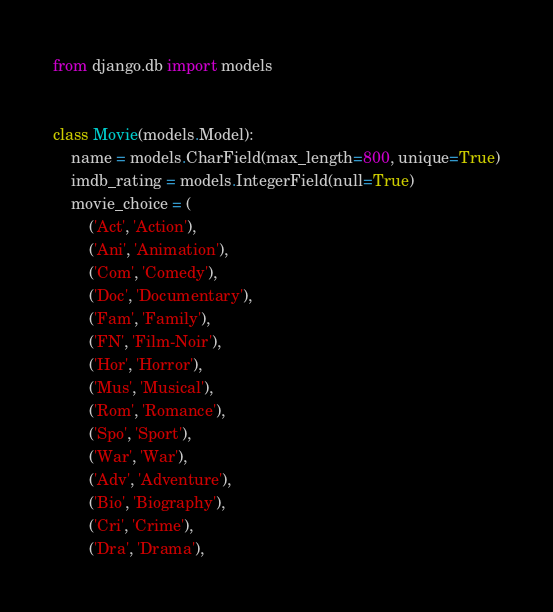<code> <loc_0><loc_0><loc_500><loc_500><_Python_>from django.db import models


class Movie(models.Model):
    name = models.CharField(max_length=800, unique=True)
    imdb_rating = models.IntegerField(null=True)
    movie_choice = (
        ('Act', 'Action'),
        ('Ani', 'Animation'),
        ('Com', 'Comedy'),
        ('Doc', 'Documentary'),
        ('Fam', 'Family'),
        ('FN', 'Film-Noir'),
        ('Hor', 'Horror'),
        ('Mus', 'Musical'),
        ('Rom', 'Romance'),
        ('Spo', 'Sport'),
        ('War', 'War'),
        ('Adv', 'Adventure'),
        ('Bio', 'Biography'),
        ('Cri', 'Crime'),
        ('Dra', 'Drama'),</code> 